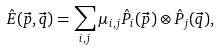Convert formula to latex. <formula><loc_0><loc_0><loc_500><loc_500>\hat { E } ( \vec { p } , \vec { q } ) = \sum _ { i , j } \mu _ { i , j } \hat { P } _ { i } ( \vec { p } ) \otimes \hat { P } _ { j } ( \vec { q } ) ,</formula> 